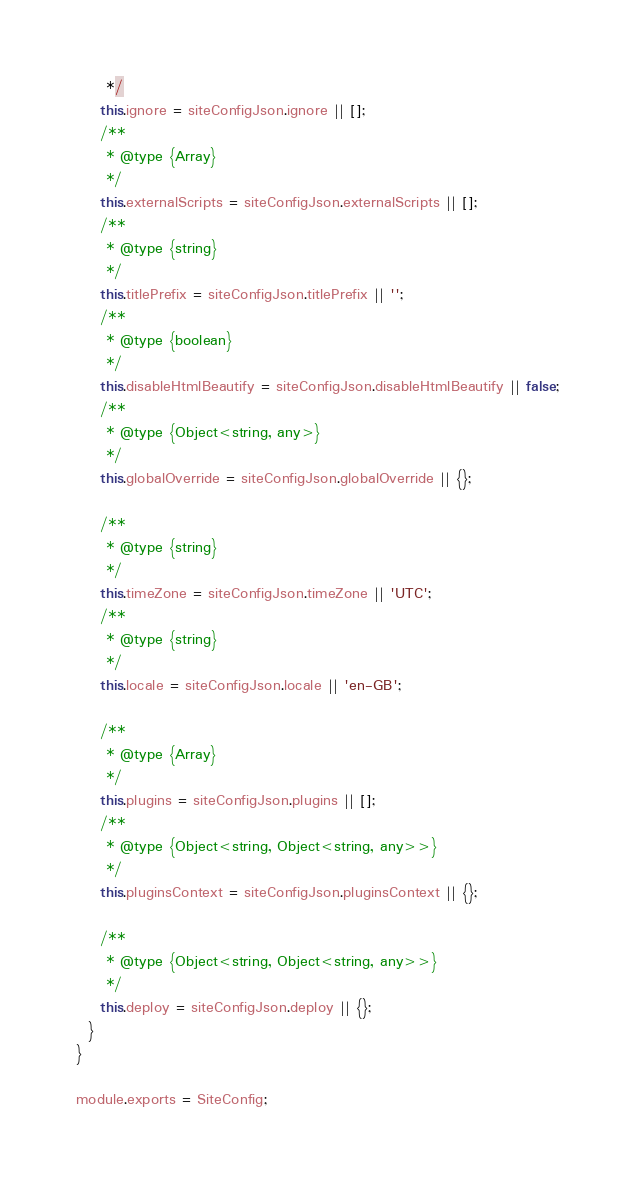Convert code to text. <code><loc_0><loc_0><loc_500><loc_500><_JavaScript_>     */
    this.ignore = siteConfigJson.ignore || [];
    /**
     * @type {Array}
     */
    this.externalScripts = siteConfigJson.externalScripts || [];
    /**
     * @type {string}
     */
    this.titlePrefix = siteConfigJson.titlePrefix || '';
    /**
     * @type {boolean}
     */
    this.disableHtmlBeautify = siteConfigJson.disableHtmlBeautify || false;
    /**
     * @type {Object<string, any>}
     */
    this.globalOverride = siteConfigJson.globalOverride || {};

    /**
     * @type {string}
     */
    this.timeZone = siteConfigJson.timeZone || 'UTC';
    /**
     * @type {string}
     */
    this.locale = siteConfigJson.locale || 'en-GB';

    /**
     * @type {Array}
     */
    this.plugins = siteConfigJson.plugins || [];
    /**
     * @type {Object<string, Object<string, any>>}
     */
    this.pluginsContext = siteConfigJson.pluginsContext || {};

    /**
     * @type {Object<string, Object<string, any>>}
     */
    this.deploy = siteConfigJson.deploy || {};
  }
}

module.exports = SiteConfig;
</code> 